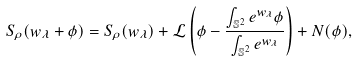<formula> <loc_0><loc_0><loc_500><loc_500>S _ { \rho } ( w _ { \lambda } + \phi ) = S _ { \rho } ( w _ { \lambda } ) + \mathcal { L } \left ( \phi - \frac { \int _ { \mathbb { S } ^ { 2 } } e ^ { w _ { \lambda } } \phi } { \int _ { \mathbb { S } ^ { 2 } } e ^ { w _ { \lambda } } } \right ) + N ( \phi ) ,</formula> 